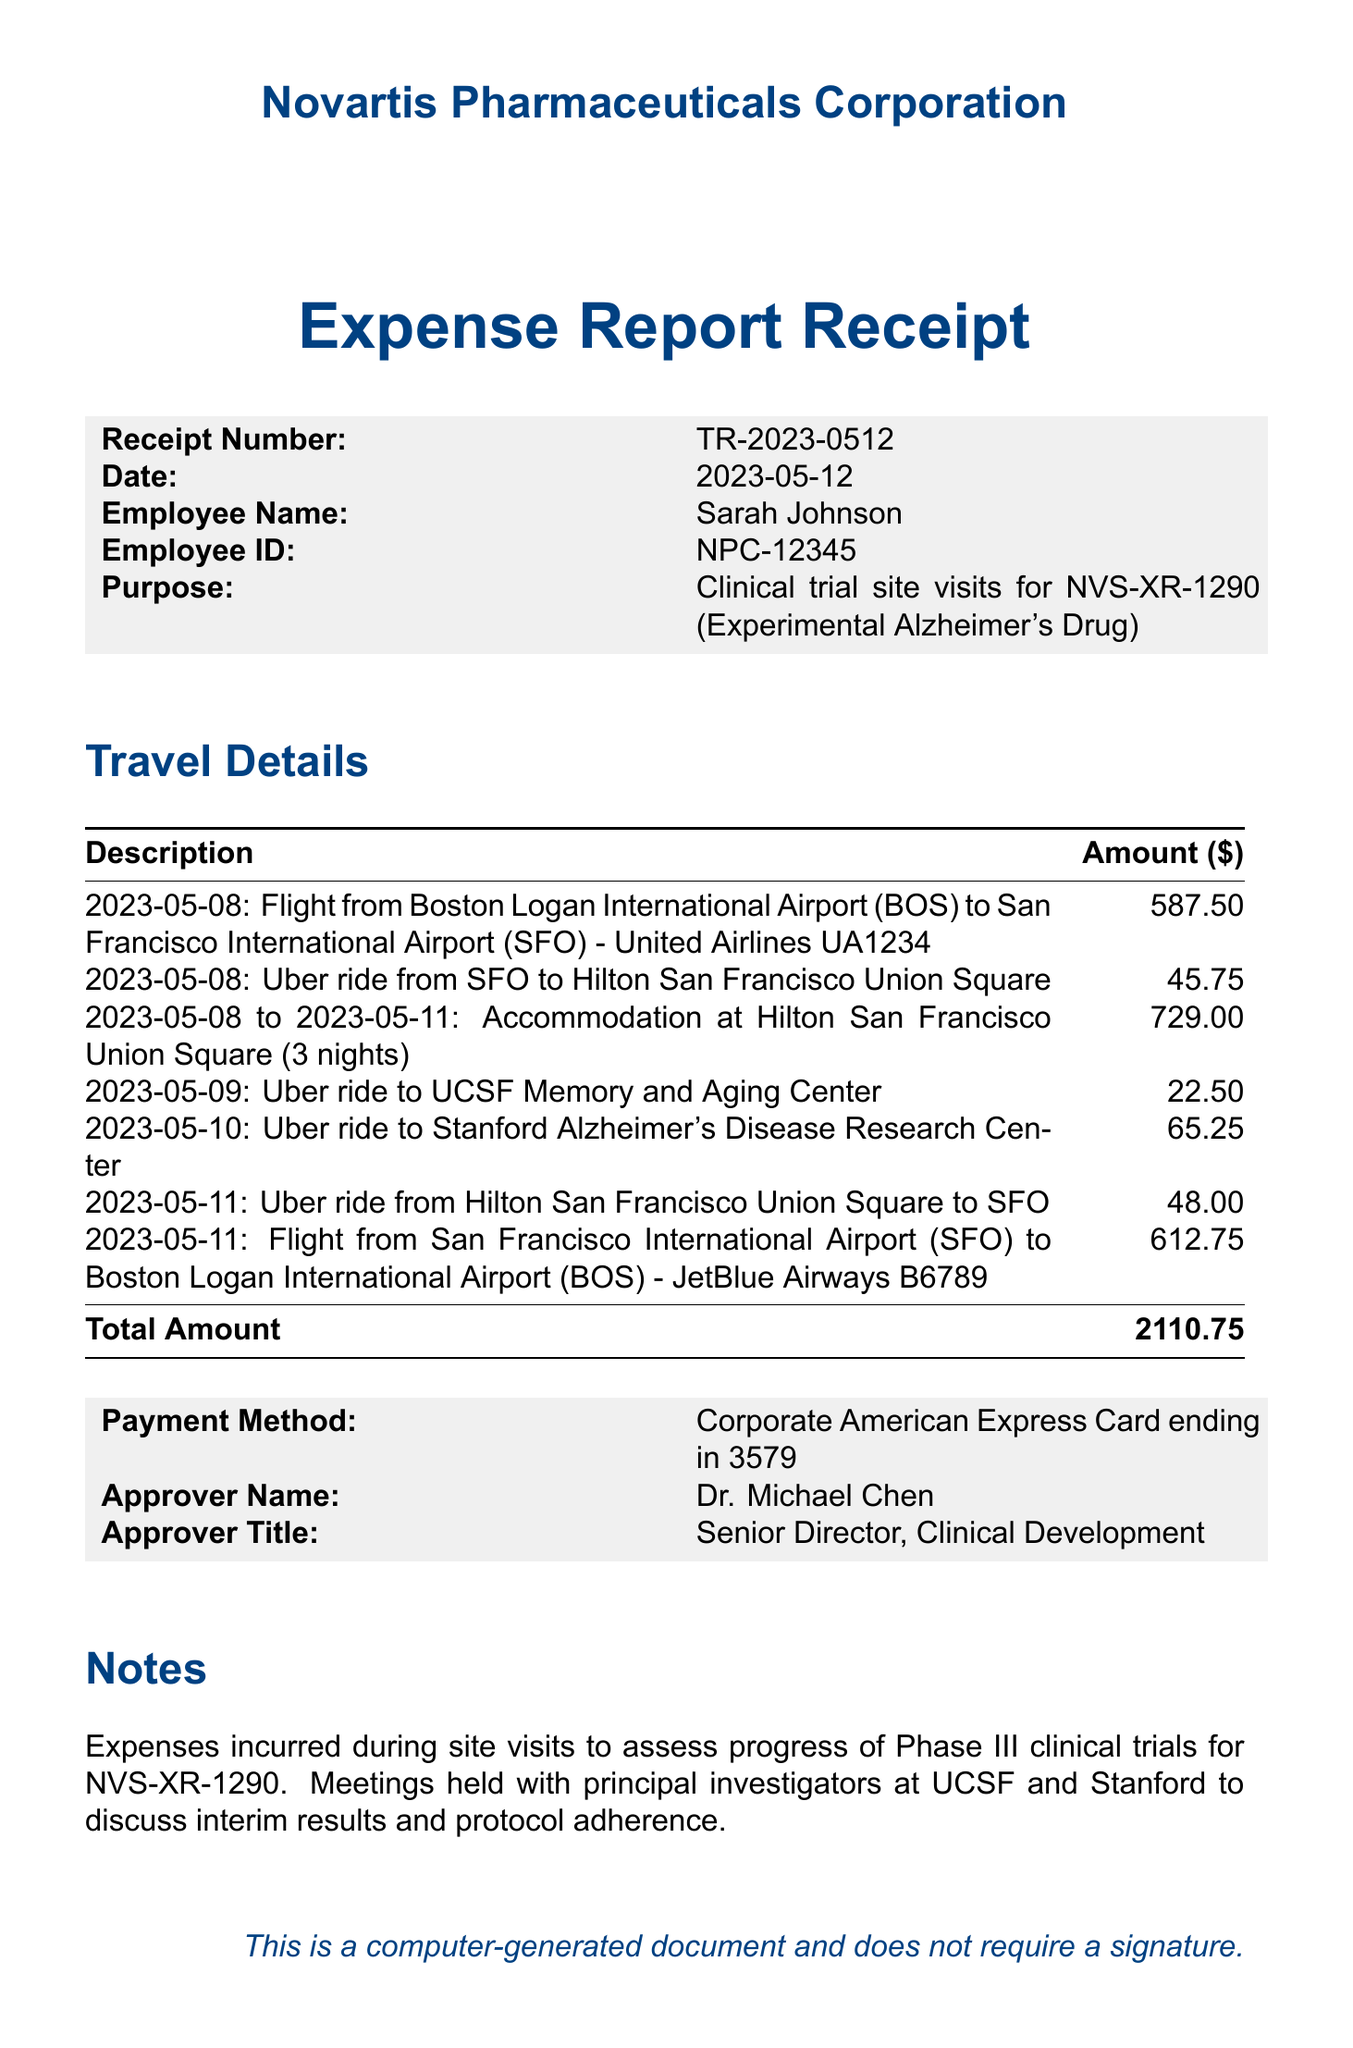What is the receipt number? The receipt number is a unique identifier for this document, listed as TR-2023-0512.
Answer: TR-2023-0512 Who is the employee associated with this receipt? The employee associated with this receipt is stated as Sarah Johnson.
Answer: Sarah Johnson What was the total amount of the expenses? The total amount of the expenses is the final figure provided in the document, which sums all travel costs.
Answer: 2110.75 How many nights did the employee stay at the hotel? The accommodation entry states a duration of 3 nights, providing the detail of the hotel stay.
Answer: 3 nights What was the purpose of the travel? The document specifies the purpose as clinical trial site visits for NVS-XR-1290, indicating the drug being assessed.
Answer: Clinical trial site visits for NVS-XR-1290 Which airline was used for the outbound flight? The airline for the flight from Boston to San Francisco is United Airlines, as listed in the travel details.
Answer: United Airlines What was the payment method used for these expenses? The method of payment for the expenses is provided as a Corporate American Express Card ending in 3579.
Answer: Corporate American Express Card ending in 3579 Who approved the expense report? The individual who approved the expense report is mentioned as Dr. Michael Chen.
Answer: Dr. Michael Chen How many Uber rides were taken during the trip? The travel details list three separate Uber rides taken during the trip, counting the entries that mention Uber.
Answer: 3 